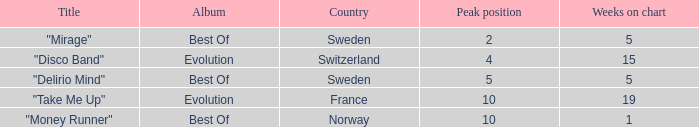What is the title of the single with the peak position of 10 and weeks on chart is less than 19? "Money Runner". 